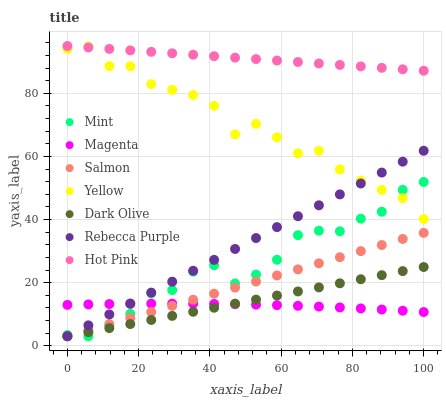Does Magenta have the minimum area under the curve?
Answer yes or no. Yes. Does Hot Pink have the maximum area under the curve?
Answer yes or no. Yes. Does Dark Olive have the minimum area under the curve?
Answer yes or no. No. Does Dark Olive have the maximum area under the curve?
Answer yes or no. No. Is Dark Olive the smoothest?
Answer yes or no. Yes. Is Yellow the roughest?
Answer yes or no. Yes. Is Salmon the smoothest?
Answer yes or no. No. Is Salmon the roughest?
Answer yes or no. No. Does Dark Olive have the lowest value?
Answer yes or no. Yes. Does Yellow have the lowest value?
Answer yes or no. No. Does Hot Pink have the highest value?
Answer yes or no. Yes. Does Dark Olive have the highest value?
Answer yes or no. No. Is Dark Olive less than Yellow?
Answer yes or no. Yes. Is Yellow greater than Dark Olive?
Answer yes or no. Yes. Does Dark Olive intersect Mint?
Answer yes or no. Yes. Is Dark Olive less than Mint?
Answer yes or no. No. Is Dark Olive greater than Mint?
Answer yes or no. No. Does Dark Olive intersect Yellow?
Answer yes or no. No. 